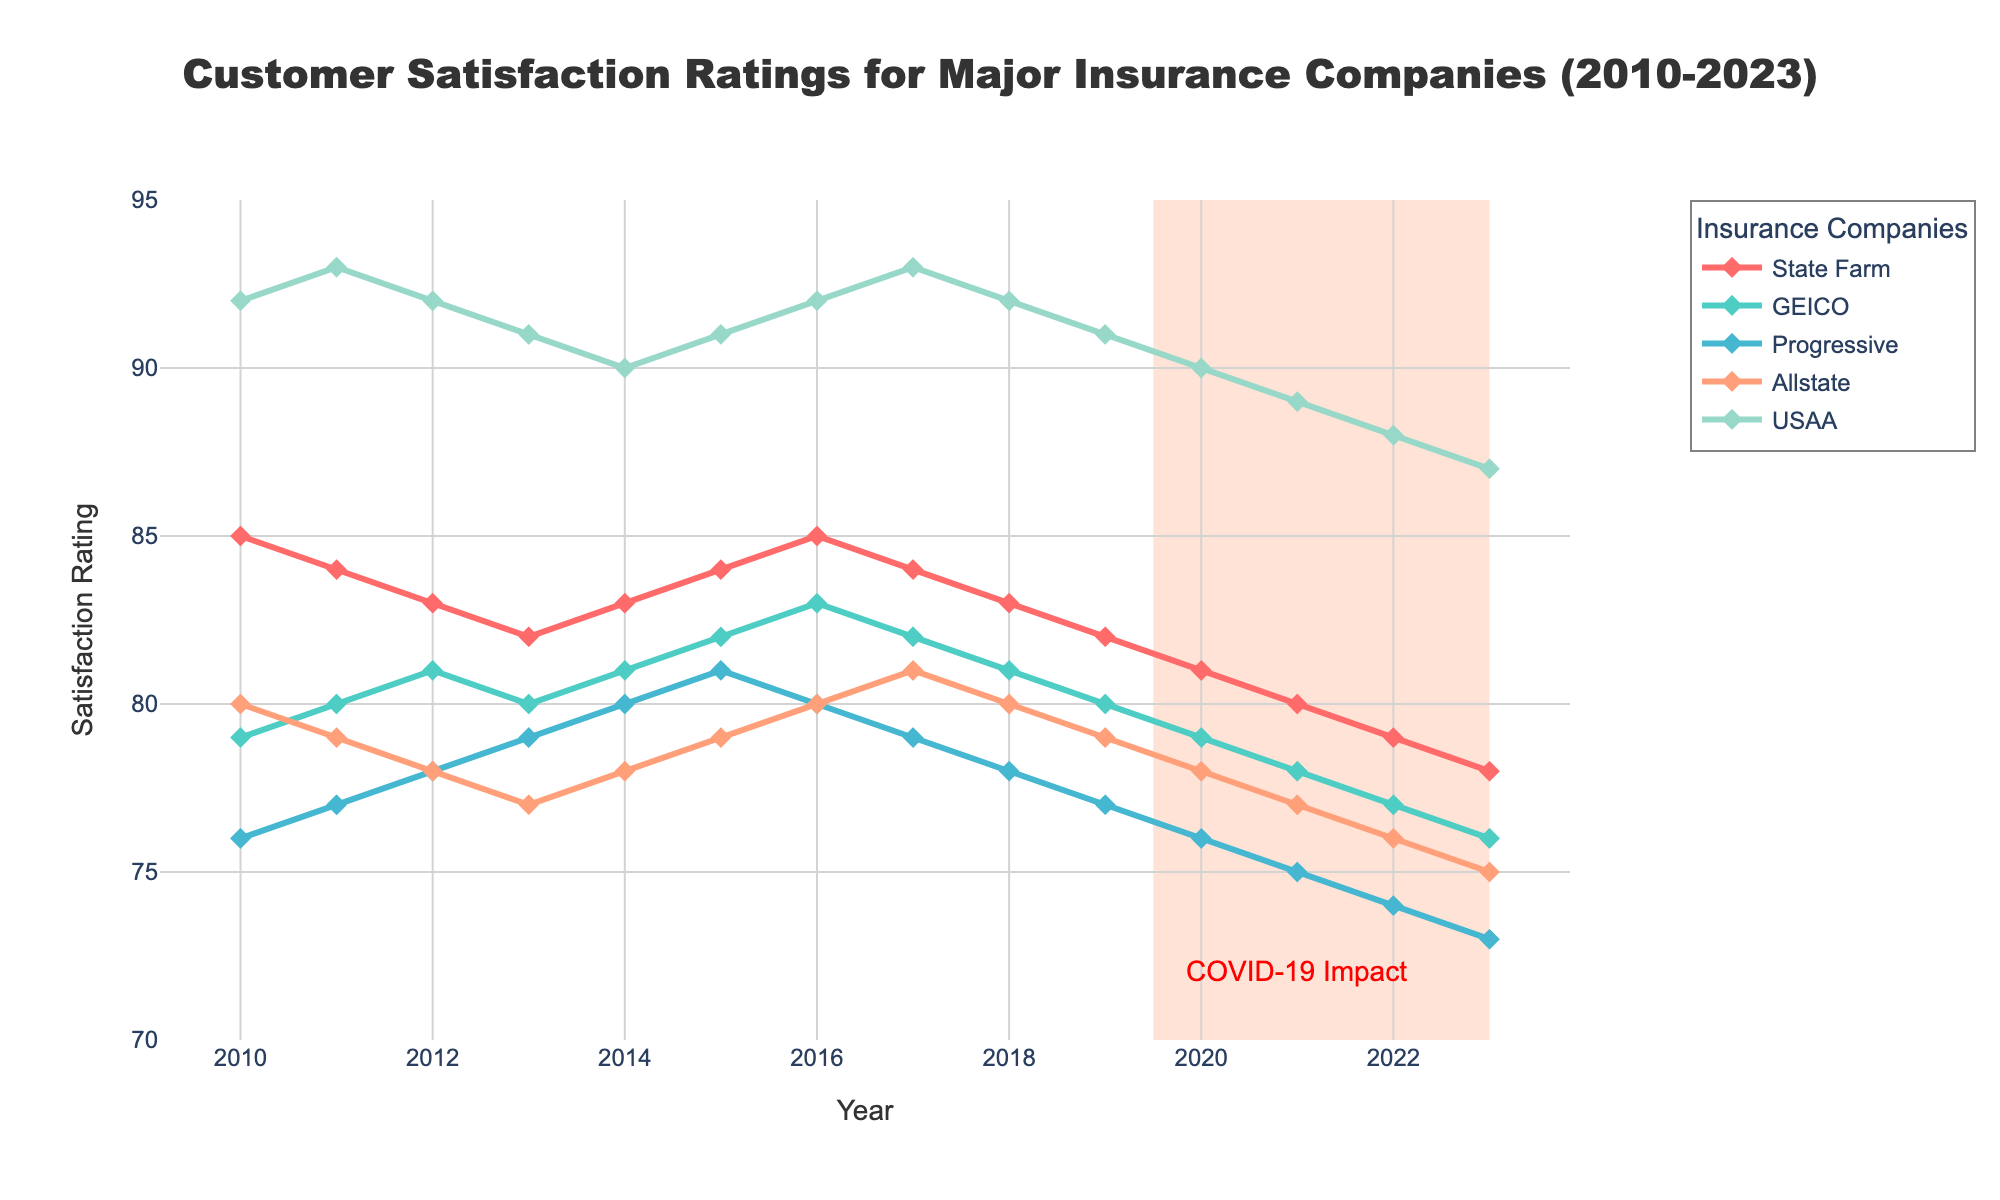Which insurance company has had the highest customer satisfaction rating consistently from 2010 to 2023? By looking at the trend lines in the figure, identify which company's line remains the highest throughout the years. USAA's line is consistently the highest among all companies from 2010 to 2023.
Answer: USAA How did State Farm's customer satisfaction rating change from 2010 to 2023? Examine the trend of State Farm's line from 2010 to 2023. Consider the starting point, ending point, and any fluctuations. State Farm's satisfaction rating decreased from 85 in 2010 to 78 in 2023, showing a gradual decline.
Answer: Decreased In which year did Progressive's customer satisfaction rating peak? By observing Progressive's line, determine the year when the value is at its highest point. Progressive's peak rating is in 2015, with a rating of 81.
Answer: 2015 Which company showed the largest overall decline in customer satisfaction from 2010 to 2023? Calculate the decline for each company by subtracting the 2023 rating from the 2010 rating, then compare the results. Progressive had the largest decline, dropping from 76 in 2010 to 73 in 2023, a decrease of 3 points.
Answer: Progressive How many companies had a satisfaction rating of 80 or above in the year 2015? Look at the values for all companies in the year 2015 and count those with ratings of 80 or above. In 2015, four companies (State Farm, GEICO, Progressive, and USAA) had ratings of 80 or above.
Answer: Four What is the combined average customer satisfaction rating of all companies in 2023? Add the satisfaction ratings of all companies in 2023, then divide by the number of companies. The combined average is (78 + 76 + 73 + 75 + 87) / 5 = 77.8.
Answer: 77.8 Between 2010 and 2023, which insurance company's customer satisfaction rating showed the least fluctuation? Compare the range (difference between maximum and minimum values) of satisfaction ratings for each company and identify the smallest range. Allstate's ratings range from 80 in 2010 to 75 in 2023, a difference of 5, which is the least fluctuation among the companies.
Answer: Allstate What visual effect indicates a possible significant event impacting customer satisfaction around 2019-2023? Identify any annotations or highlighted areas in the figure that denote a significant occurrence affecting the ratings. A light salmon-colored rectangle marks the years 2019-2023 alongside an annotation stating "COVID-19 Impact," indicating a significant event.
Answer: COVID-19 Impact Which company had a steeper decline in ratings between 2020 and 2023, GEICO or USAA? Compare the difference in ratings for GEICO and USAA between 2020 and 2023. GEICO's rating declined from 79 to 76, a decrease of 3, while USAA's rating declined from 90 to 87, a decrease of 3. Both companies had equal declines.
Answer: Both equal What can be inferred about customer satisfaction trends for all companies between 2019 and 2023? Look at the overall change in customer satisfaction ratings for all companies across the specified years. All companies show a declining trend in customer satisfaction between 2019 and 2023.
Answer: Declining 